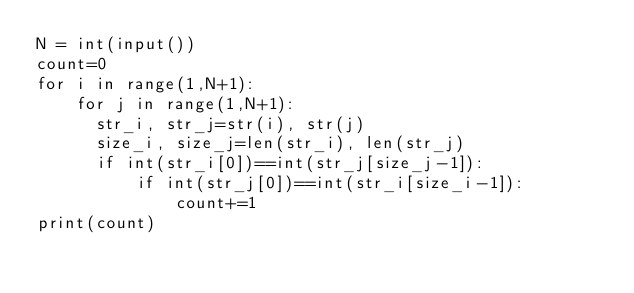<code> <loc_0><loc_0><loc_500><loc_500><_Python_>N = int(input())
count=0
for i in range(1,N+1):
    for j in range(1,N+1):
      str_i, str_j=str(i), str(j)
      size_i, size_j=len(str_i), len(str_j)
      if int(str_i[0])==int(str_j[size_j-1]):
          if int(str_j[0])==int(str_i[size_i-1]):
              count+=1
print(count)</code> 